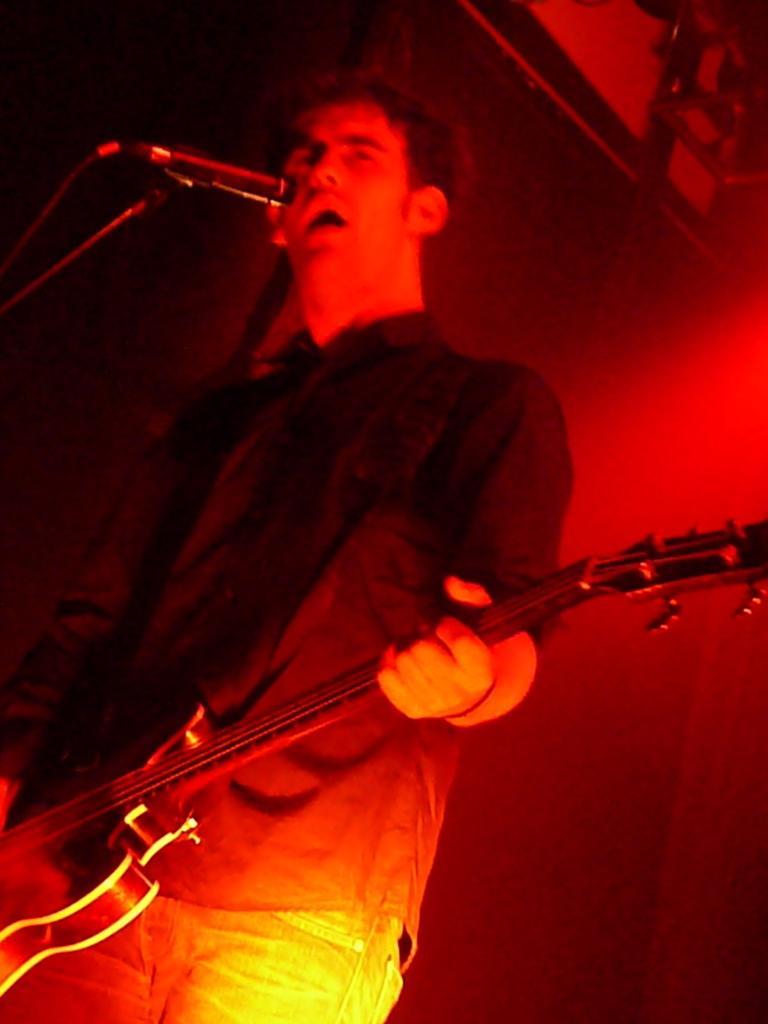Can you describe this image briefly? In the foreground of this image, there is a man holding a guitar and standing in front of a mic stand and we can also see the red light. 